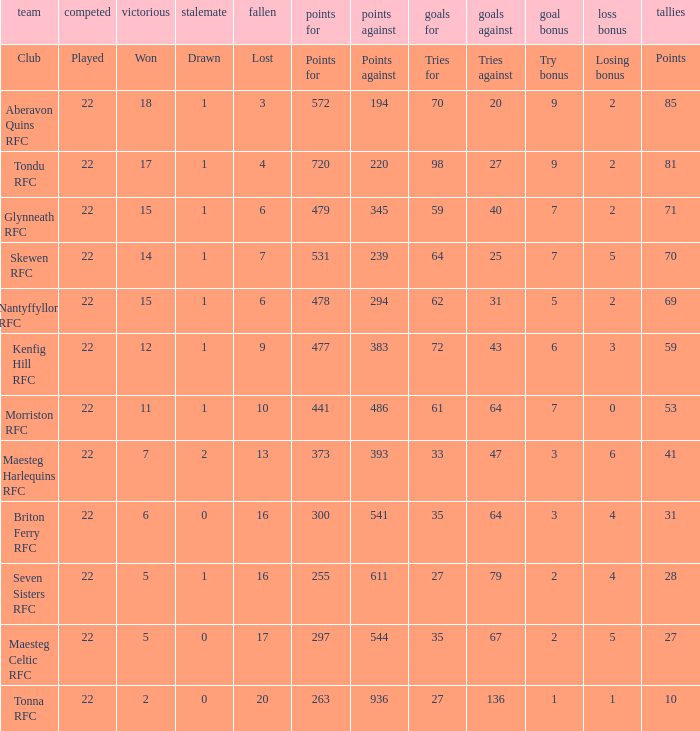How many tries against got the club with 62 tries for? 31.0. 